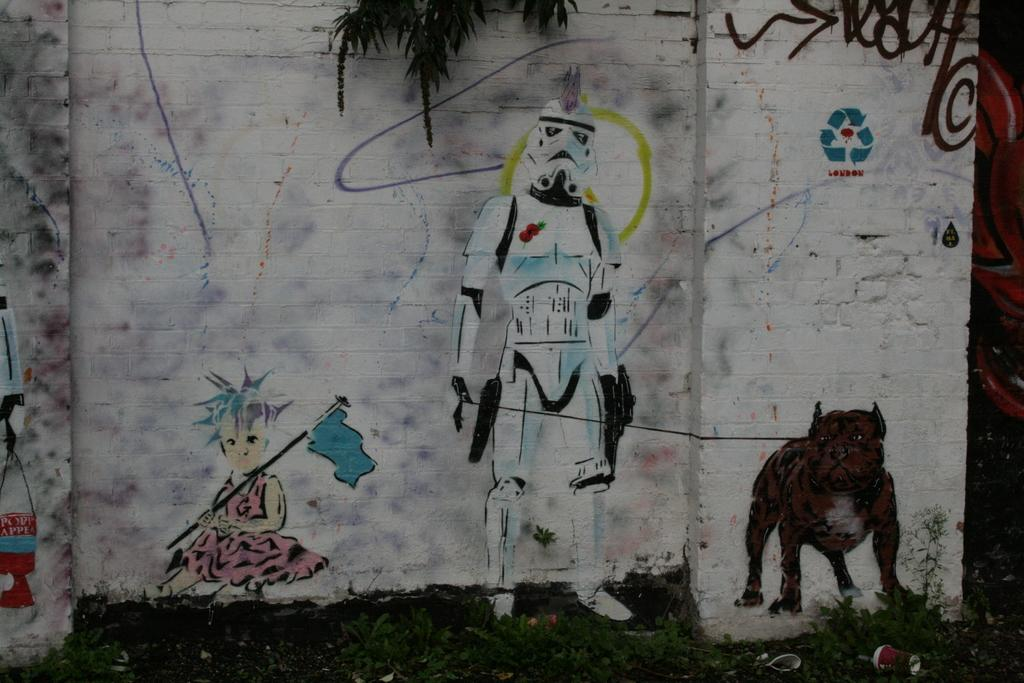What is hanging on the wall in the image? There is a painting on the wall in the image. What type of vegetation can be seen in the image? There is a tree visible in the image. What is covering the ground in the image? There is grass on the ground in the image. What type of structure is visible in the image during winter? There is no specific structure mentioned in the image, and no reference to winter is provided. 